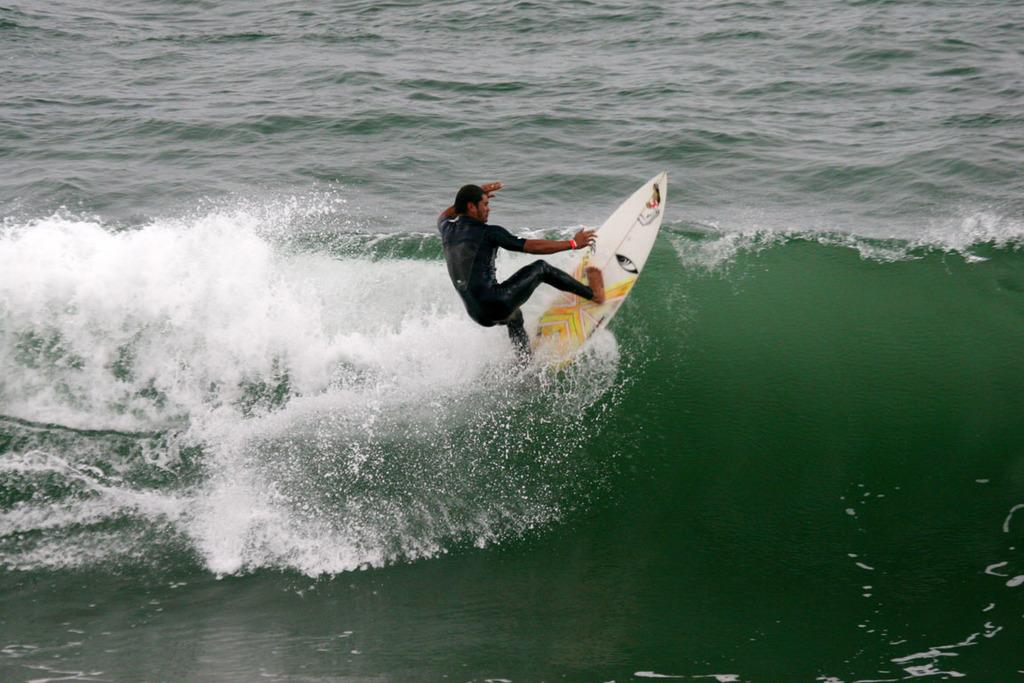What is the man in the image doing? The man is surfing in the image. Where is the man surfing? The man is surfing in the ocean. What can be seen in the background of the image? There is water visible in the image. What is the man using to surf? The man is using a surfboard in the image. What is the color of the surfboard? The surfboard is white in color. How much honey is being used by the man in the image? There is no honey present in the image; the man is surfing in the ocean. 